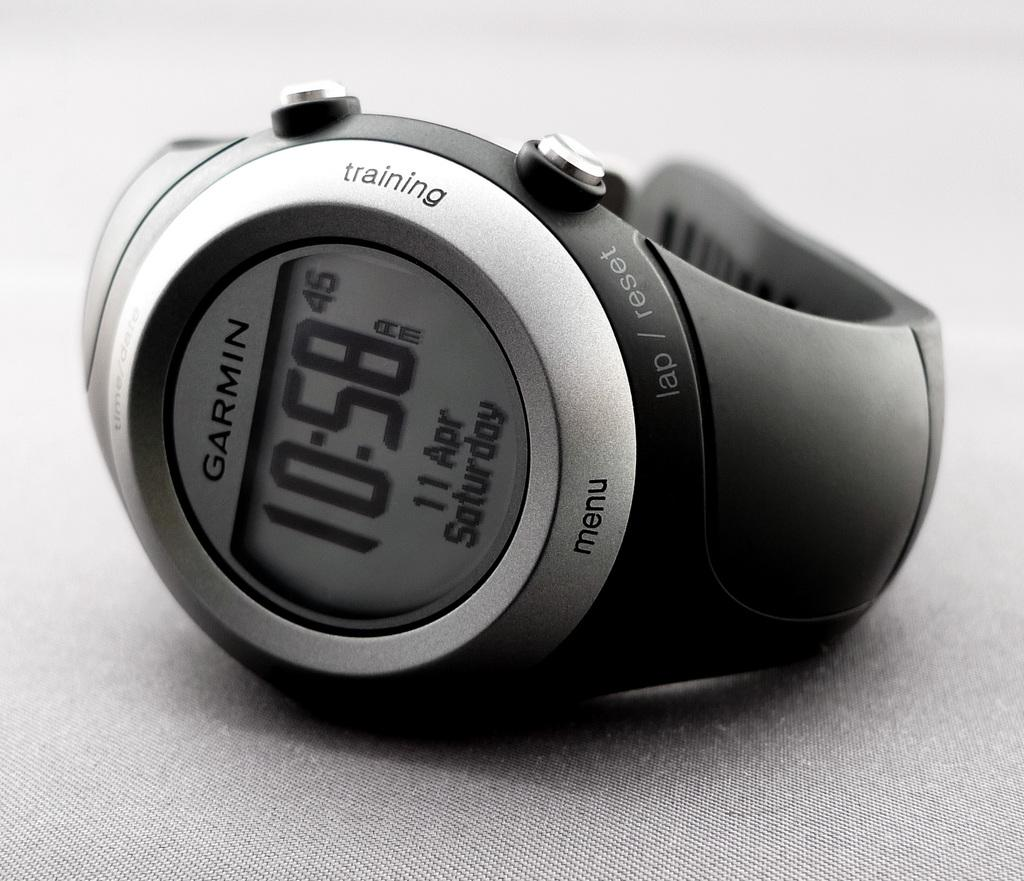<image>
Describe the image concisely. A Garmin watch sits on a smooth gray cloth 